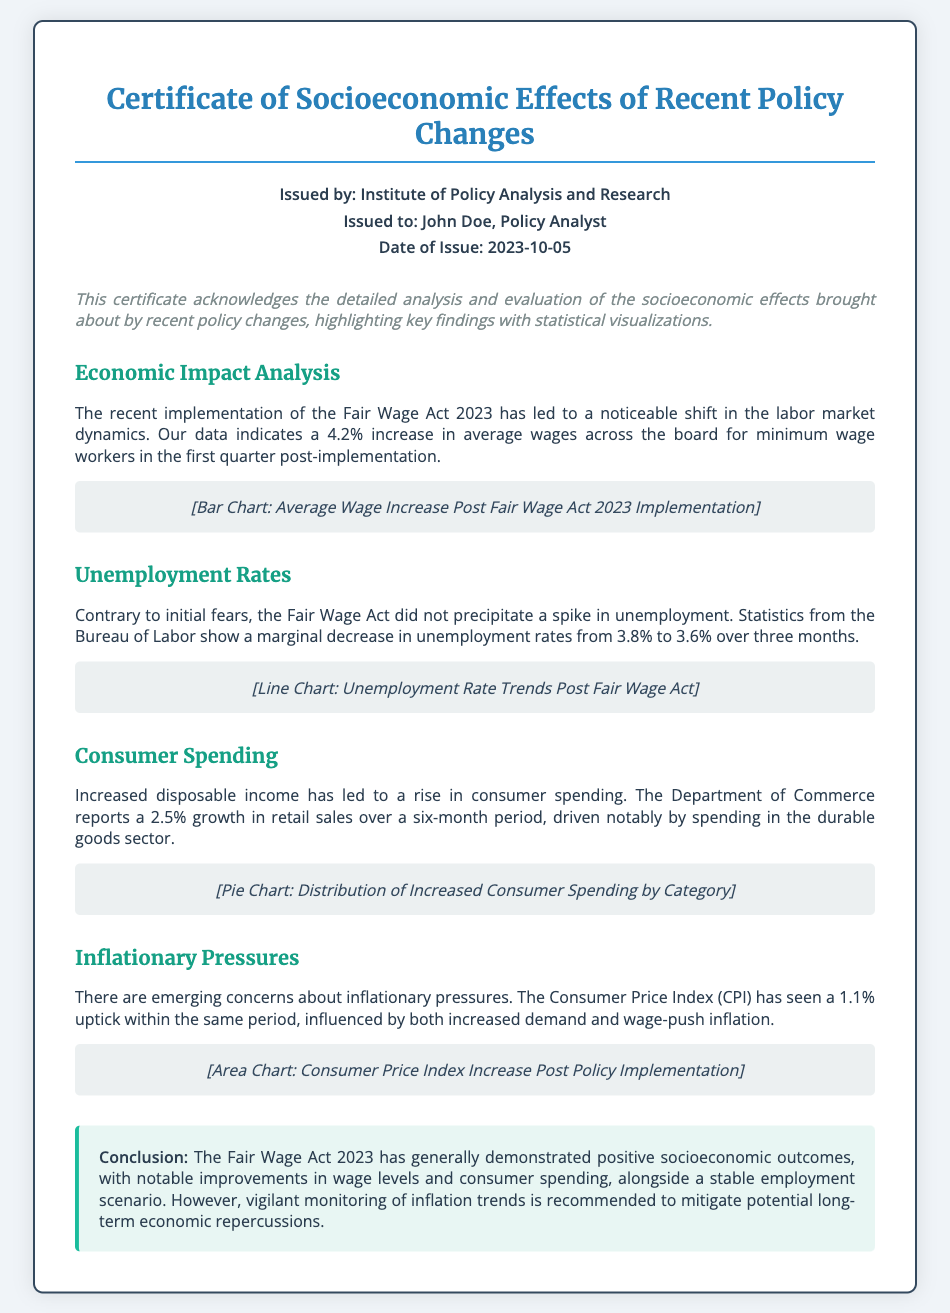what is the issue date of the certificate? The issue date is explicitly stated in the document, which is 2023-10-05.
Answer: 2023-10-05 who is the certificate issued to? The document specifies that the certificate is issued to John Doe, a Policy Analyst.
Answer: John Doe, Policy Analyst what percentage increase in average wages is reported? The document states a 4.2% increase in average wages for minimum wage workers.
Answer: 4.2% what was the unemployment rate after the Fair Wage Act implementation? The document mentions the unemployment rate decreased to 3.6%.
Answer: 3.6% what was the growth percentage in retail sales reported? According to the document, retail sales experienced a growth of 2.5%.
Answer: 2.5% what type of chart is used to represent consumer spending distribution? The document indicates a pie chart is used for representing increased consumer spending by category.
Answer: Pie Chart what is the impact of the policy on inflation according to the document? The document specifies that the Consumer Price Index saw a 1.1% uptick, indicating inflationary pressures.
Answer: 1.1% what does the conclusion recommend regarding inflation trends? The conclusion emphasizes the need for vigilant monitoring of inflation trends to mitigate potential economic repercussions.
Answer: Monitor inflation trends what significant act is analyzed in this document? The document discusses the Fair Wage Act 2023 as the significant policy change analyzed.
Answer: Fair Wage Act 2023 